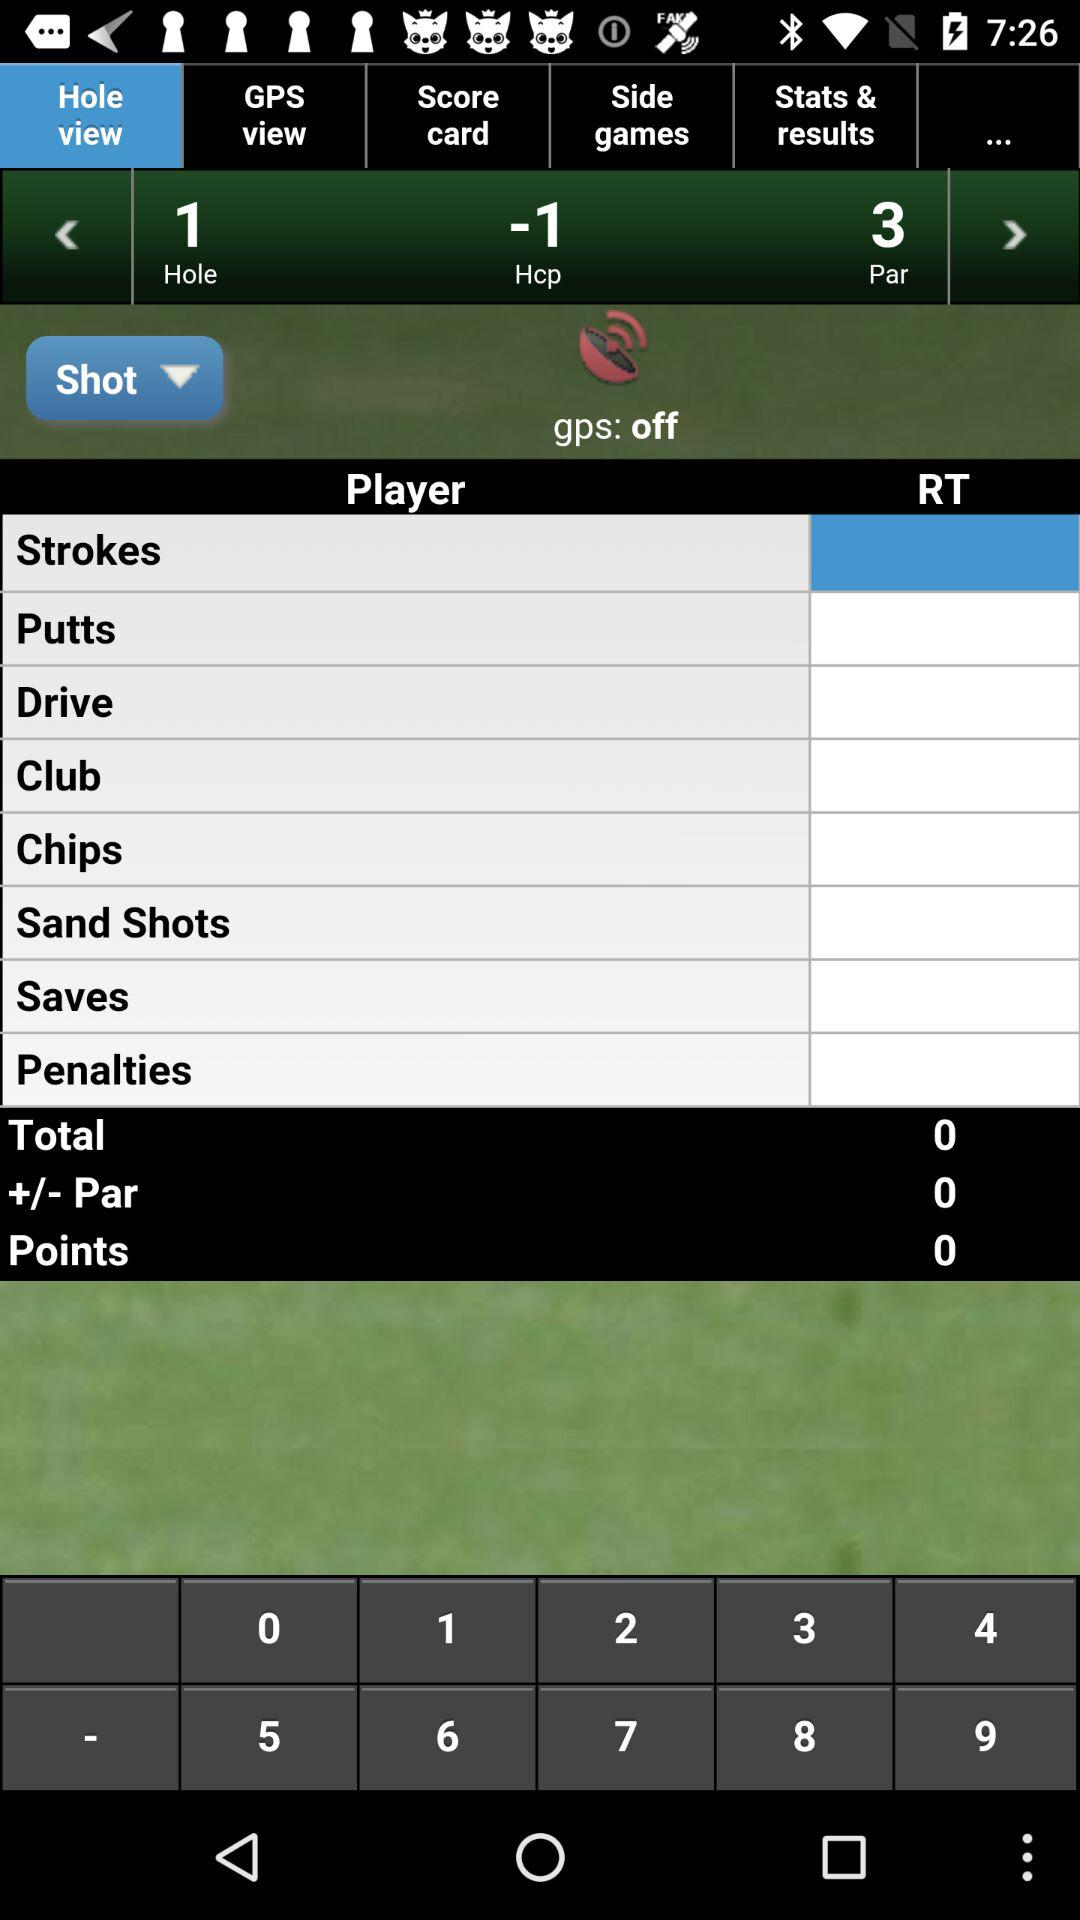What is the status of "gps"? The status of "gps" is "off". 